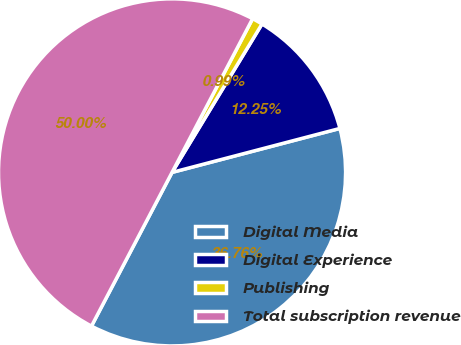Convert chart. <chart><loc_0><loc_0><loc_500><loc_500><pie_chart><fcel>Digital Media<fcel>Digital Experience<fcel>Publishing<fcel>Total subscription revenue<nl><fcel>36.76%<fcel>12.25%<fcel>0.99%<fcel>50.0%<nl></chart> 